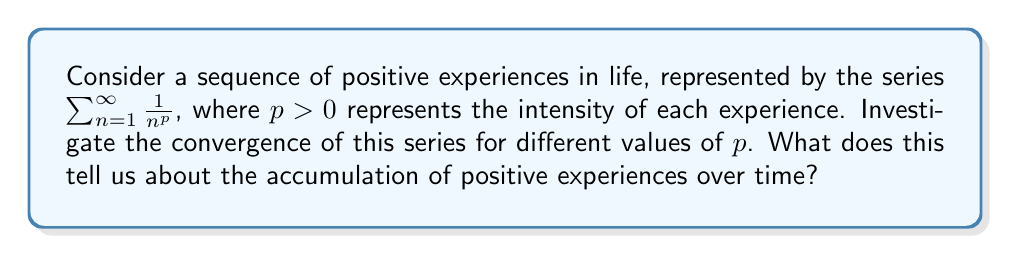Teach me how to tackle this problem. Let's approach this step-by-step:

1) The series $\sum_{n=1}^{\infty} \frac{1}{n^p}$ is known as the p-series or hyperharmonic series.

2) To investigate its convergence, we can use the integral test. Let $f(x) = \frac{1}{x^p}$ for $x \geq 1$.

3) The integral test states that if $f(x)$ is continuous, positive, and decreasing on $[1,\infty)$, then $\sum_{n=1}^{\infty} f(n)$ converges if and only if $\int_1^{\infty} f(x)dx$ converges.

4) Let's evaluate the integral:

   $$\int_1^{\infty} \frac{1}{x^p}dx = \lim_{b\to\infty} \int_1^b \frac{1}{x^p}dx = \lim_{b\to\infty} \left[\frac{x^{1-p}}{1-p}\right]_1^b$$

5) For $p \neq 1$:
   $$\lim_{b\to\infty} \left[\frac{b^{1-p}}{1-p} - \frac{1}{1-p}\right]$$

6) This limit converges if and only if $1-p < 0$, i.e., $p > 1$.

7) For $p = 1$, we get the harmonic series:
   $$\int_1^{\infty} \frac{1}{x}dx = \lim_{b\to\infty} \ln(b)$$
   which diverges.

8) Therefore, the series converges for $p > 1$ and diverges for $0 < p \leq 1$.

In the context of positive life experiences, this suggests that:
- If $p > 1$, the sum of positive experiences converges to a finite value, implying that the impact of individual experiences diminishes over time.
- If $0 < p \leq 1$, the sum diverges, suggesting that positive experiences continue to accumulate and contribute significantly over time.
Answer: The series $\sum_{n=1}^{\infty} \frac{1}{n^p}$ converges for $p > 1$ and diverges for $0 < p \leq 1$. This implies that the accumulation of positive experiences in life depends on their relative intensity: if the intensity diminishes quickly enough ($p > 1$), the total impact converges to a finite value, while if the intensity remains relatively strong ($0 < p \leq 1$), the positive experiences continue to accumulate indefinitely. 